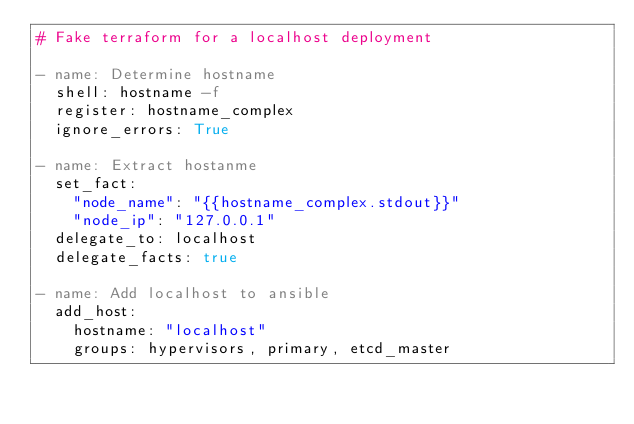<code> <loc_0><loc_0><loc_500><loc_500><_YAML_># Fake terraform for a localhost deployment

- name: Determine hostname
  shell: hostname -f
  register: hostname_complex
  ignore_errors: True

- name: Extract hostanme
  set_fact:
    "node_name": "{{hostname_complex.stdout}}"
    "node_ip": "127.0.0.1"
  delegate_to: localhost
  delegate_facts: true

- name: Add localhost to ansible
  add_host:
    hostname: "localhost"
    groups: hypervisors, primary, etcd_master
</code> 